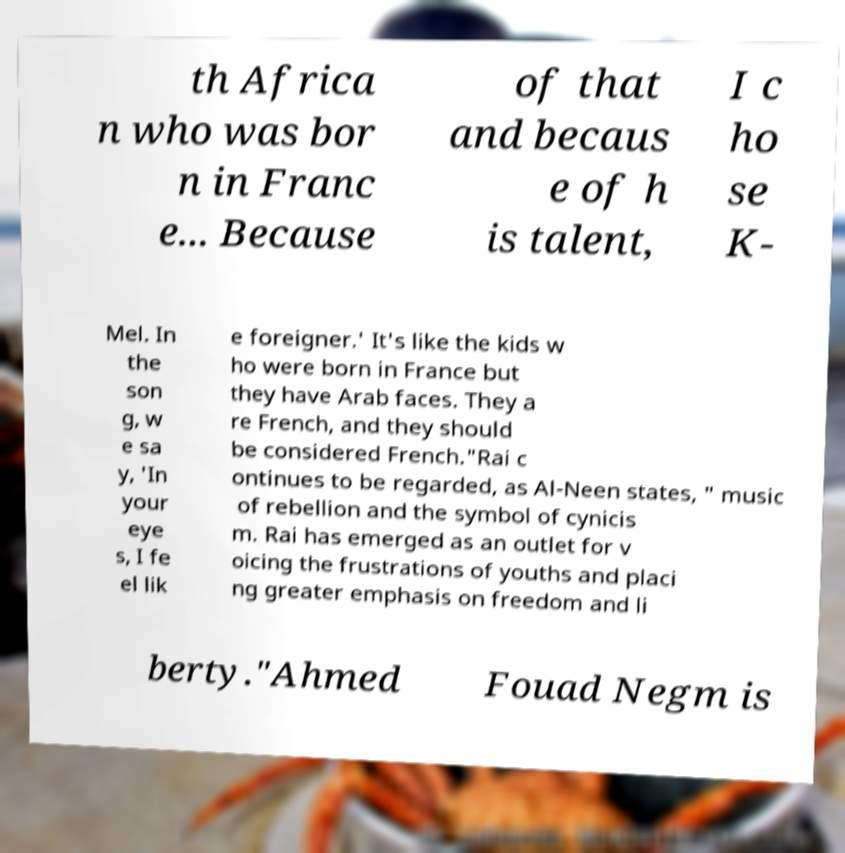I need the written content from this picture converted into text. Can you do that? th Africa n who was bor n in Franc e... Because of that and becaus e of h is talent, I c ho se K- Mel. In the son g, w e sa y, 'In your eye s, I fe el lik e foreigner.' It's like the kids w ho were born in France but they have Arab faces. They a re French, and they should be considered French."Rai c ontinues to be regarded, as Al-Neen states, " music of rebellion and the symbol of cynicis m. Rai has emerged as an outlet for v oicing the frustrations of youths and placi ng greater emphasis on freedom and li berty."Ahmed Fouad Negm is 